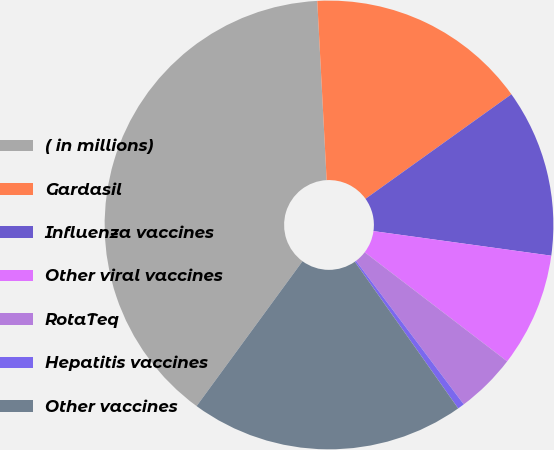Convert chart to OTSL. <chart><loc_0><loc_0><loc_500><loc_500><pie_chart><fcel>( in millions)<fcel>Gardasil<fcel>Influenza vaccines<fcel>Other viral vaccines<fcel>RotaTeq<fcel>Hepatitis vaccines<fcel>Other vaccines<nl><fcel>39.12%<fcel>15.94%<fcel>12.08%<fcel>8.21%<fcel>4.35%<fcel>0.49%<fcel>19.81%<nl></chart> 